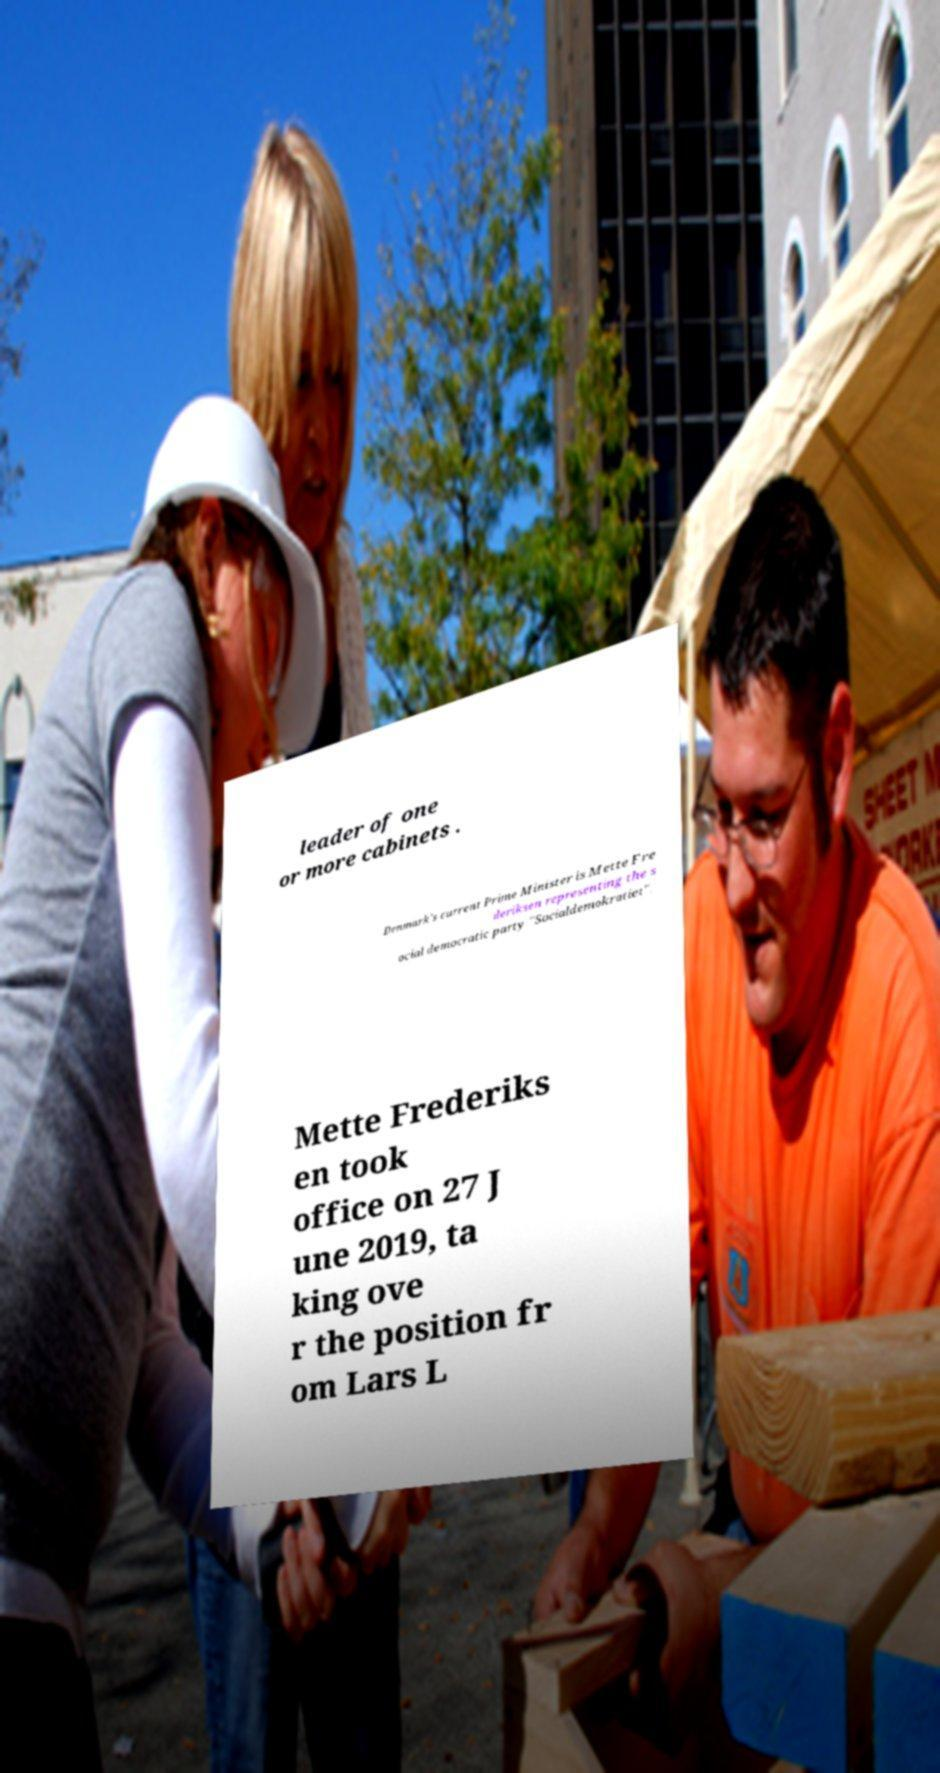Can you accurately transcribe the text from the provided image for me? leader of one or more cabinets . Denmark's current Prime Minister is Mette Fre deriksen representing the s ocial democratic party "Socialdemokratiet". Mette Frederiks en took office on 27 J une 2019, ta king ove r the position fr om Lars L 